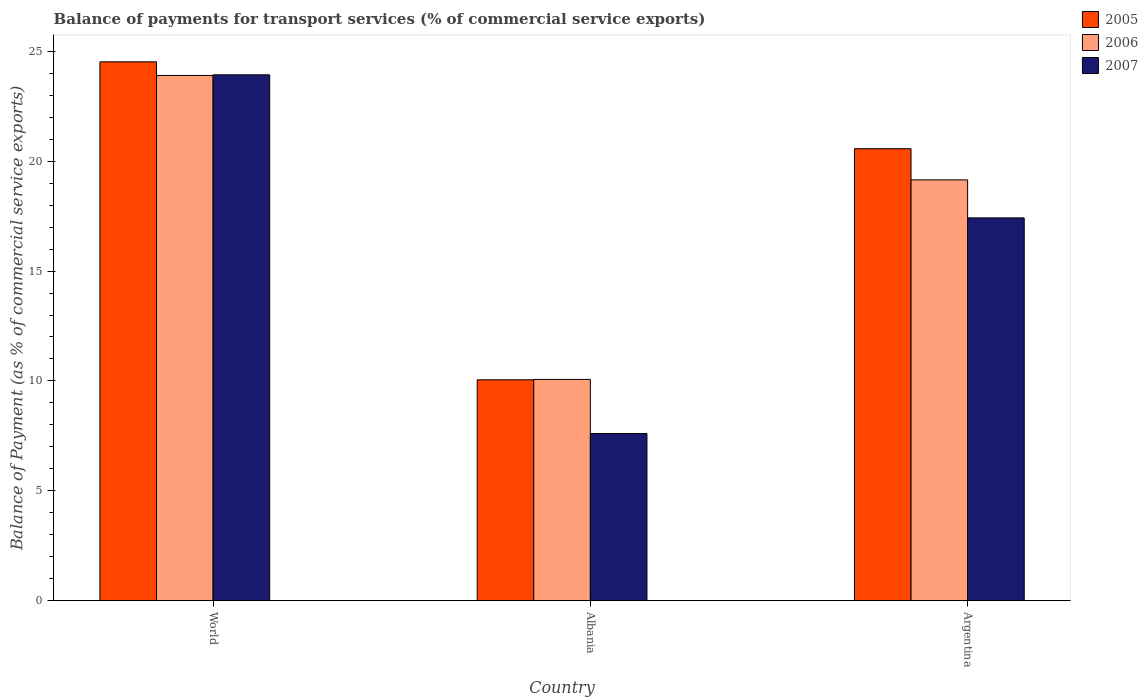How many different coloured bars are there?
Your response must be concise. 3. Are the number of bars on each tick of the X-axis equal?
Make the answer very short. Yes. How many bars are there on the 1st tick from the left?
Provide a short and direct response. 3. What is the balance of payments for transport services in 2007 in Argentina?
Keep it short and to the point. 17.42. Across all countries, what is the maximum balance of payments for transport services in 2007?
Offer a terse response. 23.93. Across all countries, what is the minimum balance of payments for transport services in 2005?
Ensure brevity in your answer.  10.05. In which country was the balance of payments for transport services in 2006 minimum?
Offer a terse response. Albania. What is the total balance of payments for transport services in 2006 in the graph?
Provide a short and direct response. 53.11. What is the difference between the balance of payments for transport services in 2007 in Albania and that in Argentina?
Provide a succinct answer. -9.81. What is the difference between the balance of payments for transport services in 2005 in Argentina and the balance of payments for transport services in 2007 in World?
Provide a short and direct response. -3.36. What is the average balance of payments for transport services in 2007 per country?
Give a very brief answer. 16.32. What is the difference between the balance of payments for transport services of/in 2005 and balance of payments for transport services of/in 2006 in Argentina?
Your response must be concise. 1.42. What is the ratio of the balance of payments for transport services in 2006 in Albania to that in World?
Provide a short and direct response. 0.42. Is the balance of payments for transport services in 2006 in Argentina less than that in World?
Provide a succinct answer. Yes. What is the difference between the highest and the second highest balance of payments for transport services in 2007?
Offer a very short reply. 9.81. What is the difference between the highest and the lowest balance of payments for transport services in 2007?
Offer a very short reply. 16.32. In how many countries, is the balance of payments for transport services in 2005 greater than the average balance of payments for transport services in 2005 taken over all countries?
Offer a very short reply. 2. Is the sum of the balance of payments for transport services in 2007 in Albania and Argentina greater than the maximum balance of payments for transport services in 2005 across all countries?
Offer a terse response. Yes. What does the 3rd bar from the left in Argentina represents?
Keep it short and to the point. 2007. Is it the case that in every country, the sum of the balance of payments for transport services in 2006 and balance of payments for transport services in 2007 is greater than the balance of payments for transport services in 2005?
Your answer should be very brief. Yes. Are all the bars in the graph horizontal?
Your answer should be very brief. No. How many countries are there in the graph?
Offer a terse response. 3. Are the values on the major ticks of Y-axis written in scientific E-notation?
Ensure brevity in your answer.  No. Does the graph contain grids?
Ensure brevity in your answer.  No. What is the title of the graph?
Ensure brevity in your answer.  Balance of payments for transport services (% of commercial service exports). What is the label or title of the Y-axis?
Offer a terse response. Balance of Payment (as % of commercial service exports). What is the Balance of Payment (as % of commercial service exports) of 2005 in World?
Your response must be concise. 24.52. What is the Balance of Payment (as % of commercial service exports) in 2006 in World?
Ensure brevity in your answer.  23.9. What is the Balance of Payment (as % of commercial service exports) in 2007 in World?
Offer a terse response. 23.93. What is the Balance of Payment (as % of commercial service exports) of 2005 in Albania?
Your answer should be compact. 10.05. What is the Balance of Payment (as % of commercial service exports) in 2006 in Albania?
Provide a succinct answer. 10.07. What is the Balance of Payment (as % of commercial service exports) of 2007 in Albania?
Provide a succinct answer. 7.61. What is the Balance of Payment (as % of commercial service exports) in 2005 in Argentina?
Ensure brevity in your answer.  20.57. What is the Balance of Payment (as % of commercial service exports) of 2006 in Argentina?
Offer a very short reply. 19.15. What is the Balance of Payment (as % of commercial service exports) of 2007 in Argentina?
Provide a short and direct response. 17.42. Across all countries, what is the maximum Balance of Payment (as % of commercial service exports) in 2005?
Ensure brevity in your answer.  24.52. Across all countries, what is the maximum Balance of Payment (as % of commercial service exports) of 2006?
Keep it short and to the point. 23.9. Across all countries, what is the maximum Balance of Payment (as % of commercial service exports) in 2007?
Offer a terse response. 23.93. Across all countries, what is the minimum Balance of Payment (as % of commercial service exports) in 2005?
Offer a terse response. 10.05. Across all countries, what is the minimum Balance of Payment (as % of commercial service exports) in 2006?
Your answer should be very brief. 10.07. Across all countries, what is the minimum Balance of Payment (as % of commercial service exports) in 2007?
Provide a short and direct response. 7.61. What is the total Balance of Payment (as % of commercial service exports) in 2005 in the graph?
Make the answer very short. 55.14. What is the total Balance of Payment (as % of commercial service exports) in 2006 in the graph?
Offer a terse response. 53.11. What is the total Balance of Payment (as % of commercial service exports) of 2007 in the graph?
Your response must be concise. 48.95. What is the difference between the Balance of Payment (as % of commercial service exports) in 2005 in World and that in Albania?
Provide a succinct answer. 14.46. What is the difference between the Balance of Payment (as % of commercial service exports) in 2006 in World and that in Albania?
Provide a succinct answer. 13.83. What is the difference between the Balance of Payment (as % of commercial service exports) in 2007 in World and that in Albania?
Offer a terse response. 16.32. What is the difference between the Balance of Payment (as % of commercial service exports) of 2005 in World and that in Argentina?
Provide a short and direct response. 3.95. What is the difference between the Balance of Payment (as % of commercial service exports) in 2006 in World and that in Argentina?
Make the answer very short. 4.75. What is the difference between the Balance of Payment (as % of commercial service exports) of 2007 in World and that in Argentina?
Give a very brief answer. 6.51. What is the difference between the Balance of Payment (as % of commercial service exports) of 2005 in Albania and that in Argentina?
Your answer should be compact. -10.51. What is the difference between the Balance of Payment (as % of commercial service exports) of 2006 in Albania and that in Argentina?
Your answer should be very brief. -9.08. What is the difference between the Balance of Payment (as % of commercial service exports) of 2007 in Albania and that in Argentina?
Your response must be concise. -9.81. What is the difference between the Balance of Payment (as % of commercial service exports) of 2005 in World and the Balance of Payment (as % of commercial service exports) of 2006 in Albania?
Offer a terse response. 14.45. What is the difference between the Balance of Payment (as % of commercial service exports) of 2005 in World and the Balance of Payment (as % of commercial service exports) of 2007 in Albania?
Provide a short and direct response. 16.91. What is the difference between the Balance of Payment (as % of commercial service exports) of 2006 in World and the Balance of Payment (as % of commercial service exports) of 2007 in Albania?
Your answer should be compact. 16.29. What is the difference between the Balance of Payment (as % of commercial service exports) of 2005 in World and the Balance of Payment (as % of commercial service exports) of 2006 in Argentina?
Offer a terse response. 5.37. What is the difference between the Balance of Payment (as % of commercial service exports) in 2005 in World and the Balance of Payment (as % of commercial service exports) in 2007 in Argentina?
Offer a terse response. 7.1. What is the difference between the Balance of Payment (as % of commercial service exports) in 2006 in World and the Balance of Payment (as % of commercial service exports) in 2007 in Argentina?
Ensure brevity in your answer.  6.48. What is the difference between the Balance of Payment (as % of commercial service exports) in 2005 in Albania and the Balance of Payment (as % of commercial service exports) in 2006 in Argentina?
Provide a short and direct response. -9.09. What is the difference between the Balance of Payment (as % of commercial service exports) in 2005 in Albania and the Balance of Payment (as % of commercial service exports) in 2007 in Argentina?
Your answer should be very brief. -7.37. What is the difference between the Balance of Payment (as % of commercial service exports) of 2006 in Albania and the Balance of Payment (as % of commercial service exports) of 2007 in Argentina?
Your response must be concise. -7.35. What is the average Balance of Payment (as % of commercial service exports) of 2005 per country?
Offer a terse response. 18.38. What is the average Balance of Payment (as % of commercial service exports) in 2006 per country?
Offer a terse response. 17.7. What is the average Balance of Payment (as % of commercial service exports) of 2007 per country?
Offer a very short reply. 16.32. What is the difference between the Balance of Payment (as % of commercial service exports) in 2005 and Balance of Payment (as % of commercial service exports) in 2006 in World?
Your answer should be very brief. 0.62. What is the difference between the Balance of Payment (as % of commercial service exports) of 2005 and Balance of Payment (as % of commercial service exports) of 2007 in World?
Your response must be concise. 0.59. What is the difference between the Balance of Payment (as % of commercial service exports) in 2006 and Balance of Payment (as % of commercial service exports) in 2007 in World?
Your answer should be very brief. -0.03. What is the difference between the Balance of Payment (as % of commercial service exports) of 2005 and Balance of Payment (as % of commercial service exports) of 2006 in Albania?
Give a very brief answer. -0.02. What is the difference between the Balance of Payment (as % of commercial service exports) of 2005 and Balance of Payment (as % of commercial service exports) of 2007 in Albania?
Provide a short and direct response. 2.44. What is the difference between the Balance of Payment (as % of commercial service exports) in 2006 and Balance of Payment (as % of commercial service exports) in 2007 in Albania?
Ensure brevity in your answer.  2.46. What is the difference between the Balance of Payment (as % of commercial service exports) in 2005 and Balance of Payment (as % of commercial service exports) in 2006 in Argentina?
Provide a short and direct response. 1.42. What is the difference between the Balance of Payment (as % of commercial service exports) of 2005 and Balance of Payment (as % of commercial service exports) of 2007 in Argentina?
Make the answer very short. 3.15. What is the difference between the Balance of Payment (as % of commercial service exports) in 2006 and Balance of Payment (as % of commercial service exports) in 2007 in Argentina?
Offer a very short reply. 1.73. What is the ratio of the Balance of Payment (as % of commercial service exports) of 2005 in World to that in Albania?
Your response must be concise. 2.44. What is the ratio of the Balance of Payment (as % of commercial service exports) in 2006 in World to that in Albania?
Your response must be concise. 2.37. What is the ratio of the Balance of Payment (as % of commercial service exports) in 2007 in World to that in Albania?
Your response must be concise. 3.14. What is the ratio of the Balance of Payment (as % of commercial service exports) of 2005 in World to that in Argentina?
Ensure brevity in your answer.  1.19. What is the ratio of the Balance of Payment (as % of commercial service exports) of 2006 in World to that in Argentina?
Provide a short and direct response. 1.25. What is the ratio of the Balance of Payment (as % of commercial service exports) of 2007 in World to that in Argentina?
Ensure brevity in your answer.  1.37. What is the ratio of the Balance of Payment (as % of commercial service exports) in 2005 in Albania to that in Argentina?
Your answer should be very brief. 0.49. What is the ratio of the Balance of Payment (as % of commercial service exports) in 2006 in Albania to that in Argentina?
Offer a terse response. 0.53. What is the ratio of the Balance of Payment (as % of commercial service exports) in 2007 in Albania to that in Argentina?
Provide a short and direct response. 0.44. What is the difference between the highest and the second highest Balance of Payment (as % of commercial service exports) in 2005?
Ensure brevity in your answer.  3.95. What is the difference between the highest and the second highest Balance of Payment (as % of commercial service exports) in 2006?
Your answer should be compact. 4.75. What is the difference between the highest and the second highest Balance of Payment (as % of commercial service exports) in 2007?
Provide a short and direct response. 6.51. What is the difference between the highest and the lowest Balance of Payment (as % of commercial service exports) in 2005?
Your answer should be compact. 14.46. What is the difference between the highest and the lowest Balance of Payment (as % of commercial service exports) of 2006?
Offer a terse response. 13.83. What is the difference between the highest and the lowest Balance of Payment (as % of commercial service exports) in 2007?
Ensure brevity in your answer.  16.32. 